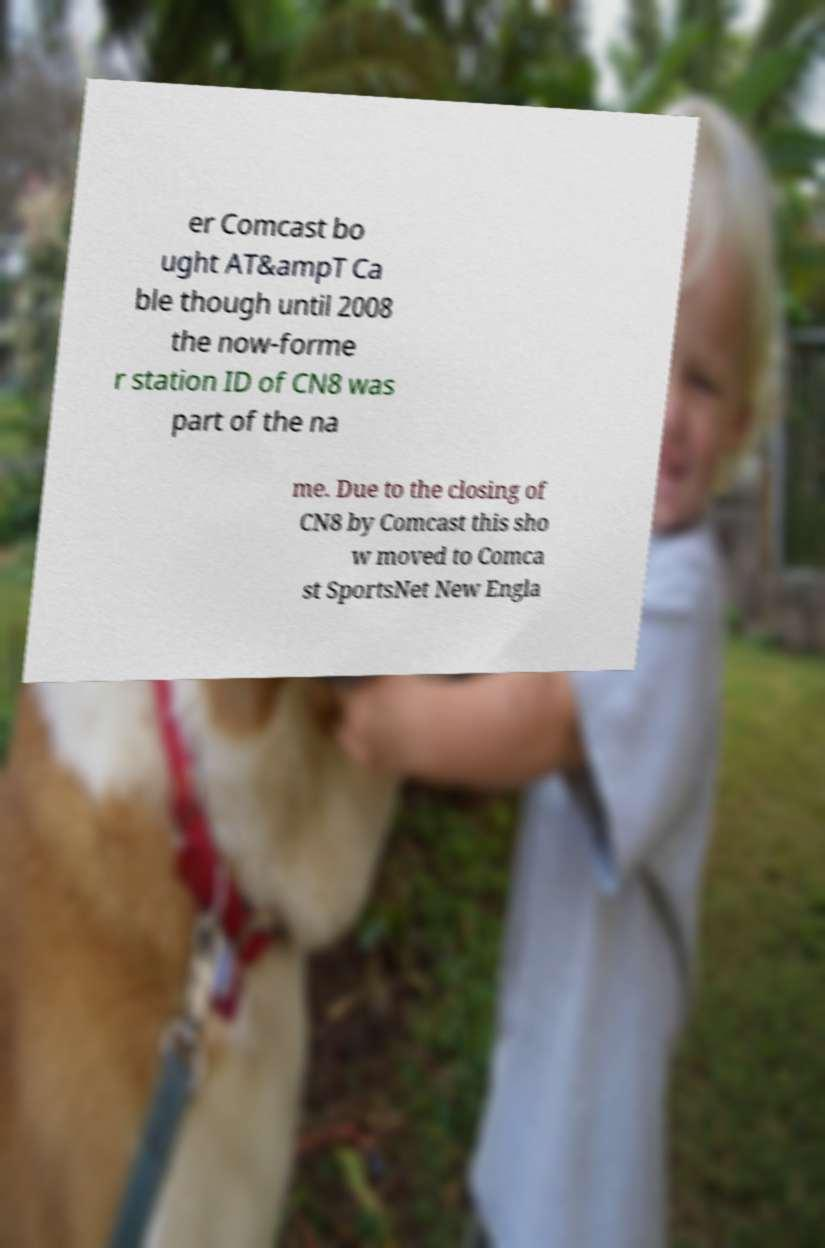What messages or text are displayed in this image? I need them in a readable, typed format. er Comcast bo ught AT&ampT Ca ble though until 2008 the now-forme r station ID of CN8 was part of the na me. Due to the closing of CN8 by Comcast this sho w moved to Comca st SportsNet New Engla 